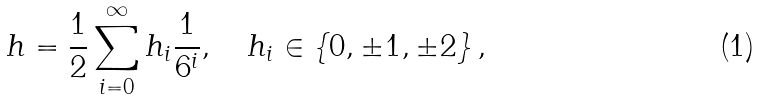<formula> <loc_0><loc_0><loc_500><loc_500>h = \frac { 1 } { 2 } \sum _ { i = 0 } ^ { \infty } h _ { i } \frac { 1 } { 6 ^ { i } } , \quad h _ { i } \in \left \{ 0 , \pm 1 , \pm 2 \right \} ,</formula> 